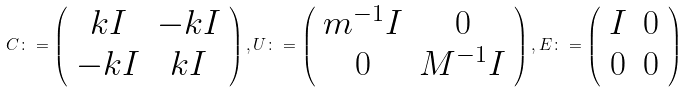<formula> <loc_0><loc_0><loc_500><loc_500>C \colon = \left ( \begin{array} { c c } k I & - k I \\ - k I & k I \end{array} \right ) , U \colon = \left ( \begin{array} { c c } m ^ { - 1 } I & 0 \\ 0 & M ^ { - 1 } I \end{array} \right ) , E \colon = \left ( \begin{array} { c c } I & 0 \\ 0 & 0 \end{array} \right )</formula> 